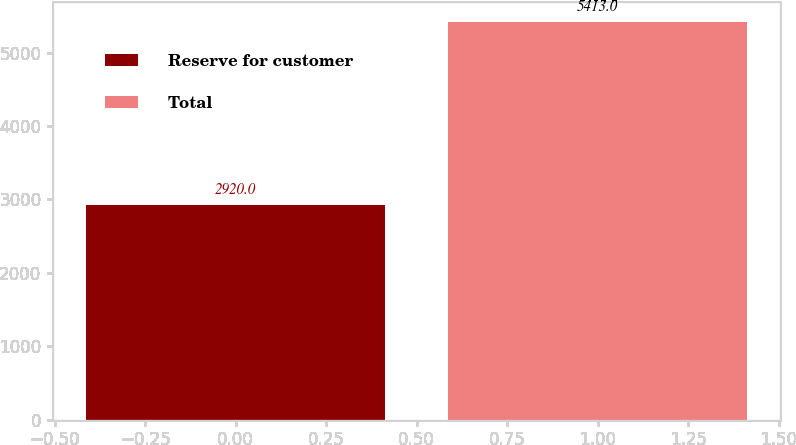<chart> <loc_0><loc_0><loc_500><loc_500><bar_chart><fcel>Reserve for customer<fcel>Total<nl><fcel>2920<fcel>5413<nl></chart> 